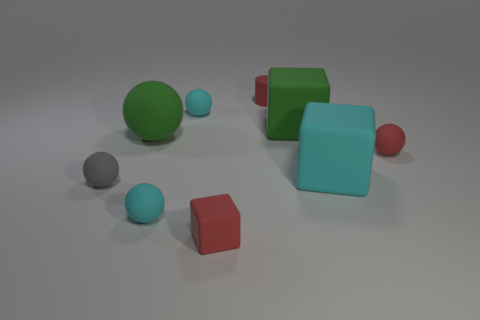Which objects in the image might logically belong to a set due to their color? The objects that might belong to a set due to their color are the two green spheres and the green cube, as they share a vibrant shade of green, visually uniting them as a group. 